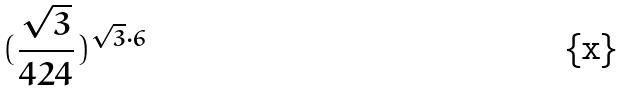<formula> <loc_0><loc_0><loc_500><loc_500>( \frac { \sqrt { 3 } } { 4 2 4 } ) ^ { \sqrt { 3 } \cdot 6 }</formula> 